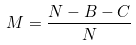Convert formula to latex. <formula><loc_0><loc_0><loc_500><loc_500>M = \frac { N - B - C } { N }</formula> 